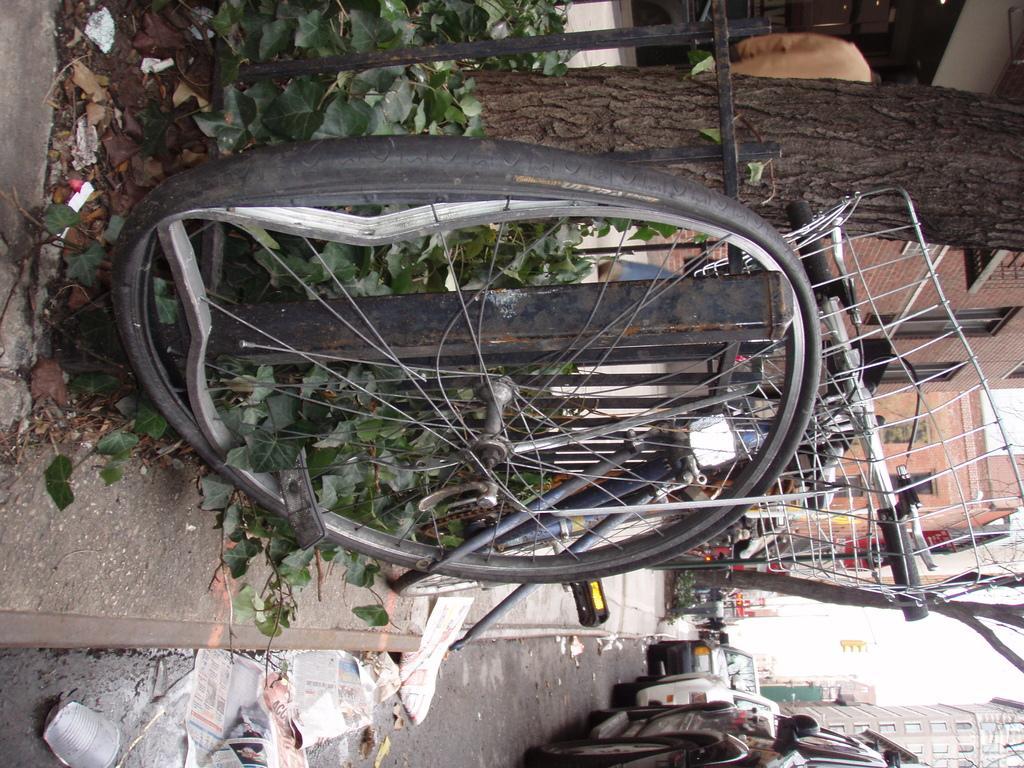Describe this image in one or two sentences. In this image we can see a bicycle placed aside on the footpath. We can also see a fence, plants, the bark of the trees and some buildings. On the bottom of the image we can see some vehicles and papers on the road. We can also see some buildings and the sky. 